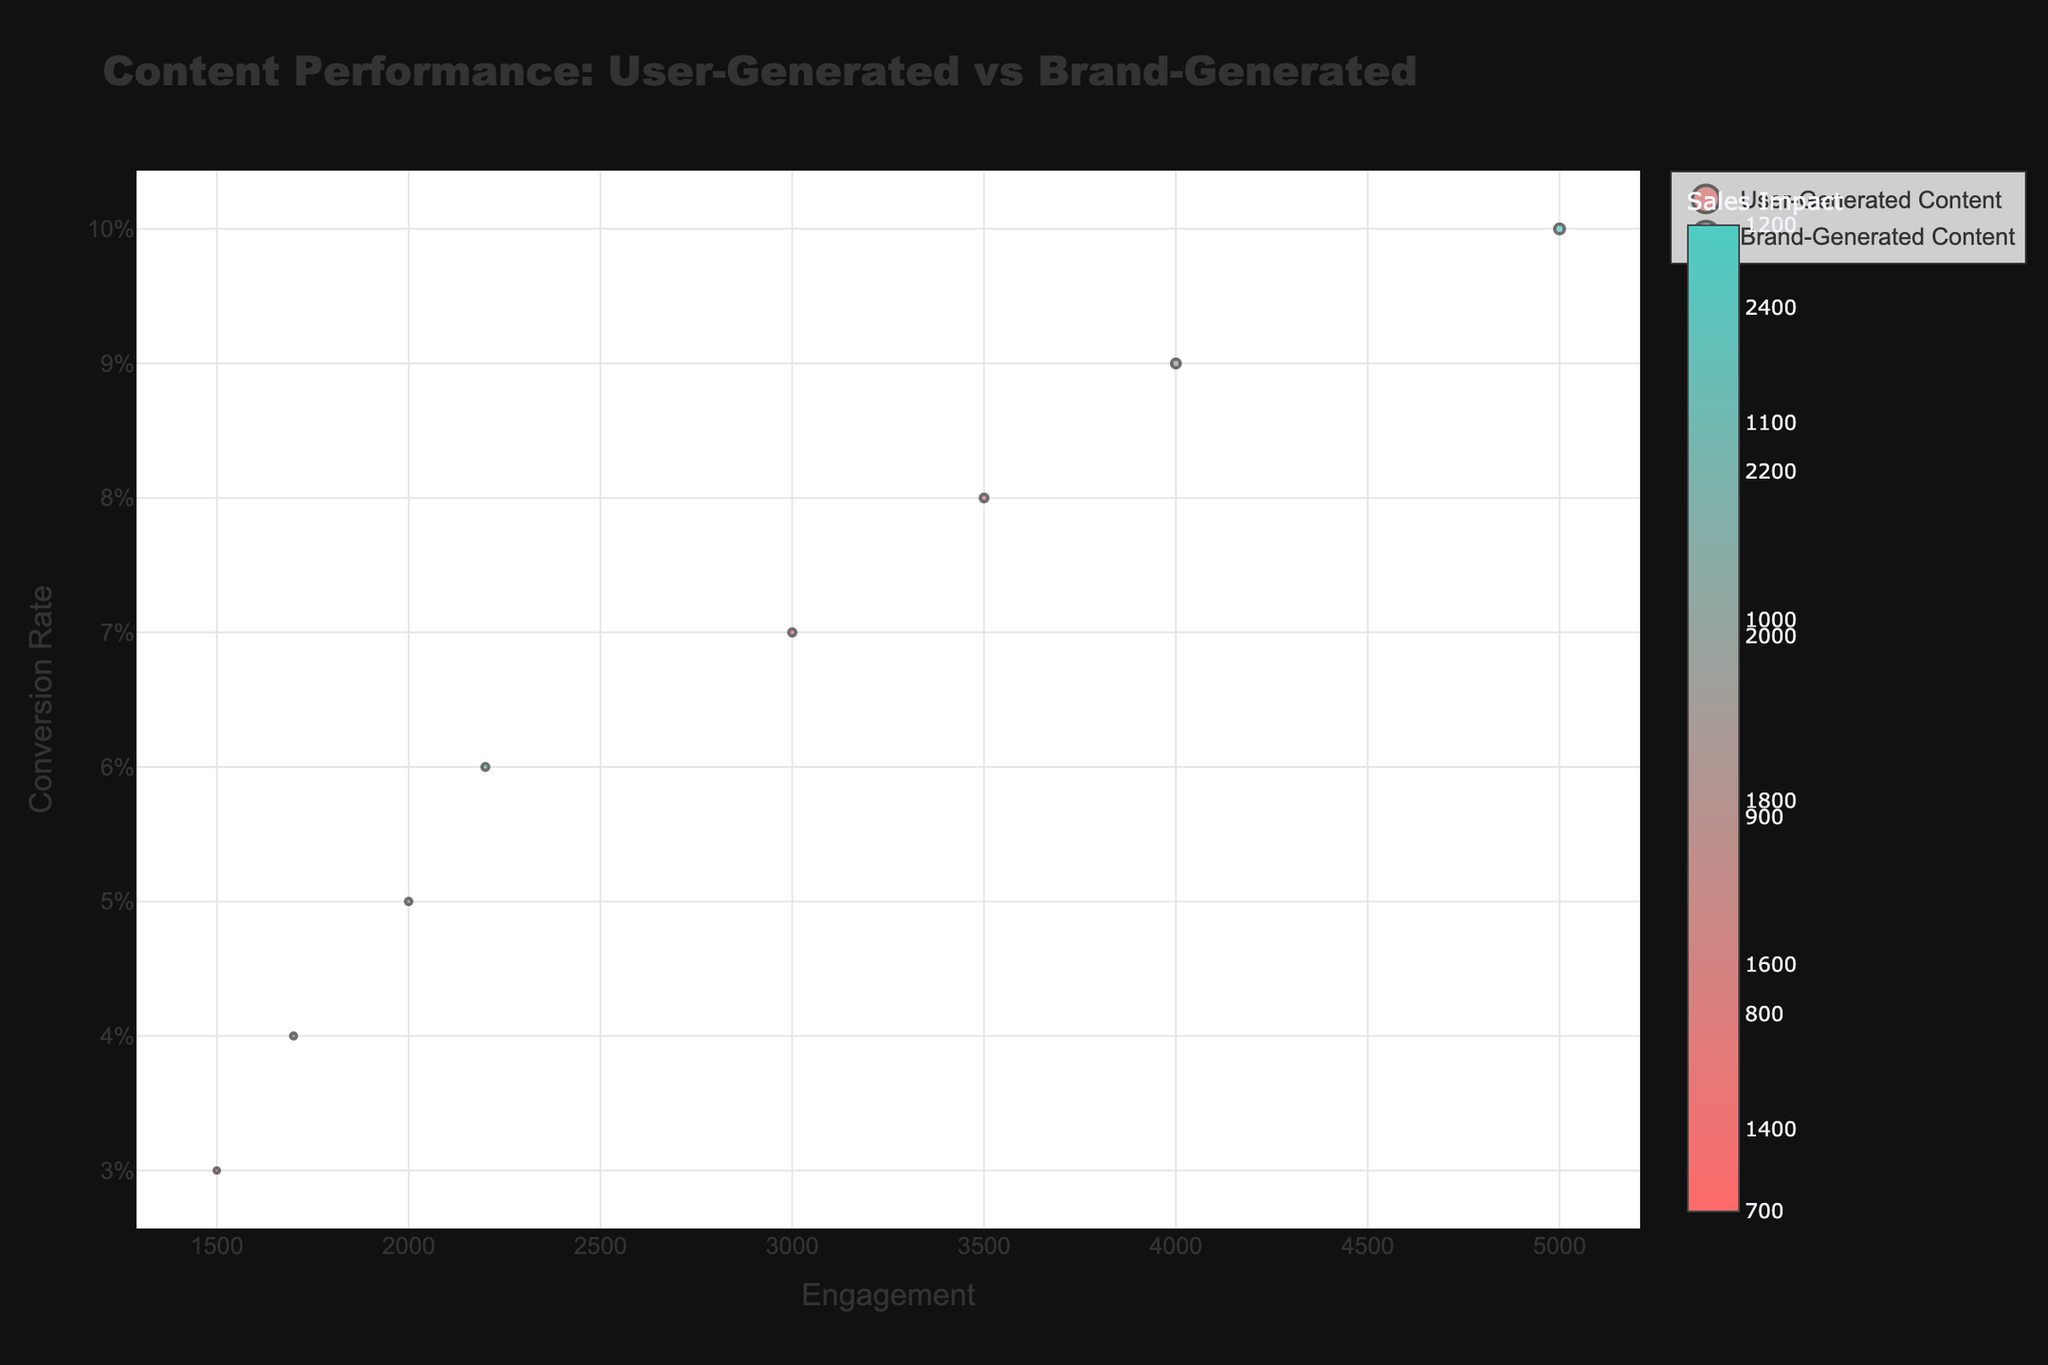What is the title of the bubble chart? The title of the bubble chart is clearly displayed at the top of the figure.
Answer: Content Performance: User-Generated vs Brand-Generated How many data points represent user-generated content? There are distinct markers in different colors representing data points, and a separate legend entry for user-generated content can help quickly identify the number of relevant dots.
Answer: 4 Which content type has the highest engagement? By checking the x-axis values for both content types, it's clear that the YouTube Review by Influencer, which is a user-generated content type, has the highest engagement.
Answer: User-Generated Content What is the conversion rate of the Instagram Post by Customer? The conversion rate can be identified by looking at the y-axis value corresponding to the specified entity in the user-generated content.
Answer: 0.08 Which brand-generated content has the highest conversion rate? To find this, compare the y-axis values of all brand-generated content markers. The Sponsored YouTube Ad has the highest position on the y-axis.
Answer: Sponsored YouTube Ad What is the average engagement for brand-generated content? Add up all engagement values for brand-generated content (2000 + 1700 + 2200 + 1500) and divide by the number of data points (4).
Answer: (2000 + 1700 + 2200 + 1500) / 4 = 1850 What is the total sales impact of all user-generated content? Sum up the sales impact values for each user-generated content data point provided.
Answer: 1500 + 2500 + 2000 + 1300 = 7300 Compare the sales impact of the Facebook Product Ad and the TikTok Customer Video. Which is higher? By looking at the size of the circles and the color shades on the chart, you can compare these two data points directly. The TikTok Customer Video has a larger and darker circle indicating a higher sales impact.
Answer: TikTok Customer Video Which data point has the highest sales impact? Identify the largest circle on the chart, which indicates the highest sales impact. The YouTube Review by Influencer stands out as the largest circle on the plot.
Answer: YouTube Review by Influencer Does user-generated content or brand-generated content generally have higher conversion rates? By comparing the positions on the y-axis for both types of content, it can be observed that user-generated content tends to be higher on the y-axis, indicating higher conversion rates on average.
Answer: User-Generated Content 